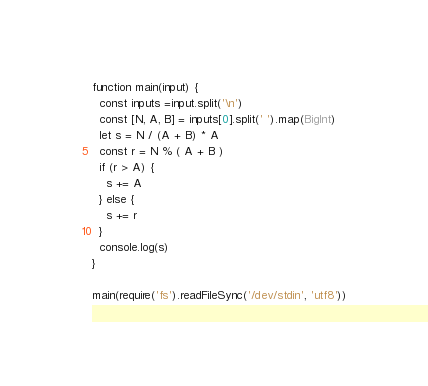<code> <loc_0><loc_0><loc_500><loc_500><_TypeScript_>function main(input) {
  const inputs =input.split('\n')
  const [N, A, B] = inputs[0].split(' ').map(BigInt)
  let s = N / (A + B) * A
  const r = N % ( A + B )
  if (r > A) {
    s += A
  } else {
    s += r
  }
  console.log(s)
}

main(require('fs').readFileSync('/dev/stdin', 'utf8'))
</code> 